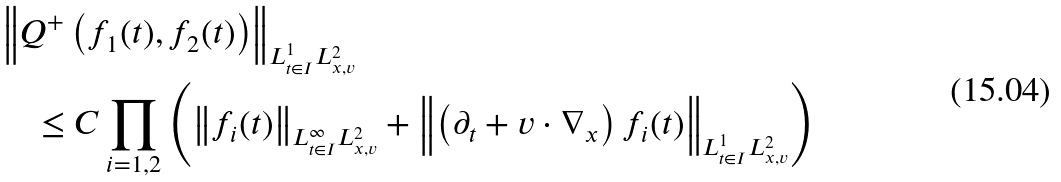<formula> <loc_0><loc_0><loc_500><loc_500>& \left \| Q ^ { + } \left ( f _ { 1 } ( t ) , f _ { 2 } ( t ) \right ) \right \| _ { L ^ { 1 } _ { t \in I } L ^ { 2 } _ { x , v } } \\ & \quad \leq C \prod _ { i = 1 , 2 } \left ( \left \| f _ { i } ( t ) \right \| _ { L ^ { \infty } _ { t \in I } L ^ { 2 } _ { x , v } } + \left \| \left ( \partial _ { t } + v \cdot \nabla _ { x } \right ) f _ { i } ( t ) \right \| _ { L ^ { 1 } _ { t \in I } L ^ { 2 } _ { x , v } } \right )</formula> 